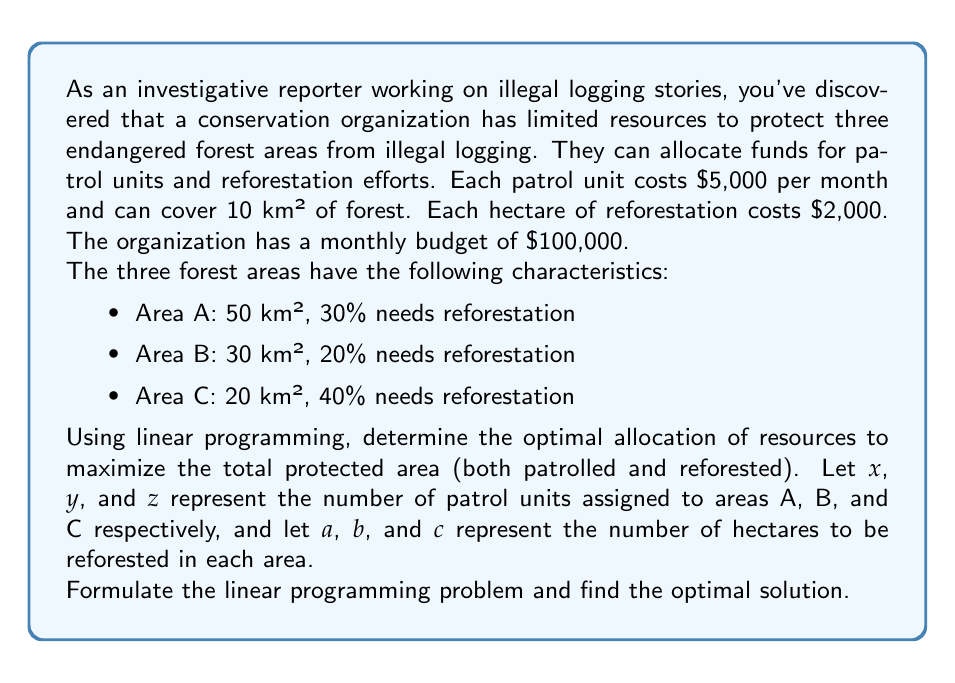Give your solution to this math problem. To solve this problem, we need to set up a linear programming model and then solve it. Let's go through this step-by-step:

1. Define the objective function:
   We want to maximize the total protected area, which includes both patrolled and reforested areas.
   
   Maximize: $Z = 10x + 10y + 10z + 0.01a + 0.01b + 0.01c$
   
   (Note: We multiply the reforested hectares by 0.01 to convert to km²)

2. Set up the constraints:

   a) Budget constraint:
      $5000x + 5000y + 5000z + 2000a + 2000b + 2000c \leq 100000$

   b) Patrol area constraints:
      Area A: $10x \leq 50$
      Area B: $10y \leq 30$
      Area C: $10z \leq 20$

   c) Reforestation area constraints:
      Area A: $a \leq 1500$ (30% of 5000 hectares)
      Area B: $b \leq 600$ (20% of 3000 hectares)
      Area C: $c \leq 800$ (40% of 2000 hectares)

   d) Non-negativity constraints:
      $x, y, z, a, b, c \geq 0$

3. Solve the linear programming problem:
   This can be done using the simplex method or linear programming software. The optimal solution is:

   $x = 5, y = 3, z = 2, a = 1500, b = 600, c = 800$

4. Interpret the results:
   - Assign 5 patrol units to Area A, 3 to Area B, and 2 to Area C
   - Reforest 1500 hectares in Area A, 600 in Area B, and 800 in Area C

5. Calculate the total protected area:
   Patrolled area: $10(5 + 3 + 2) = 100$ km²
   Reforested area: $0.01(1500 + 600 + 800) = 29$ km²
   Total protected area: $100 + 29 = 129$ km²

This solution utilizes the entire budget of $100,000:
$(5 + 3 + 2) \times 5000 + (1500 + 600 + 800) \times 2000 = 100000$
Answer: The optimal solution is to assign 5 patrol units to Area A, 3 to Area B, and 2 to Area C, while reforesting 1500 hectares in Area A, 600 in Area B, and 800 in Area C. This results in a maximum protected area of 129 km². 